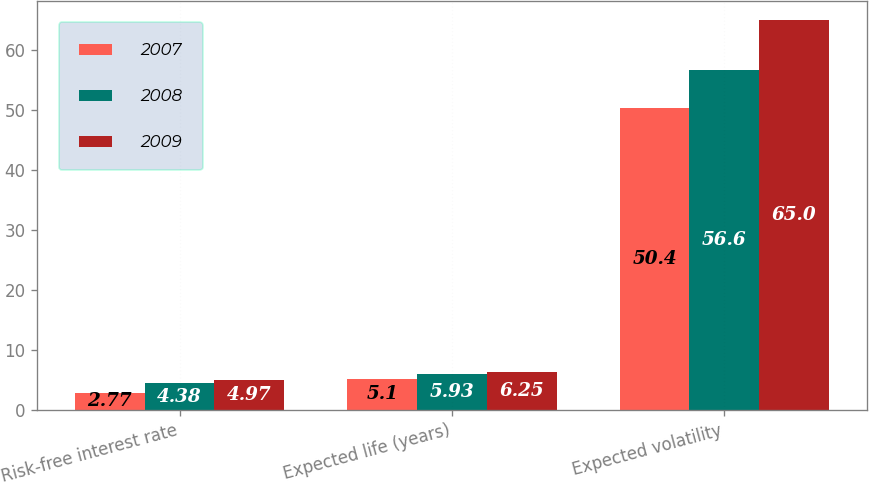<chart> <loc_0><loc_0><loc_500><loc_500><stacked_bar_chart><ecel><fcel>Risk-free interest rate<fcel>Expected life (years)<fcel>Expected volatility<nl><fcel>2007<fcel>2.77<fcel>5.1<fcel>50.4<nl><fcel>2008<fcel>4.38<fcel>5.93<fcel>56.6<nl><fcel>2009<fcel>4.97<fcel>6.25<fcel>65<nl></chart> 